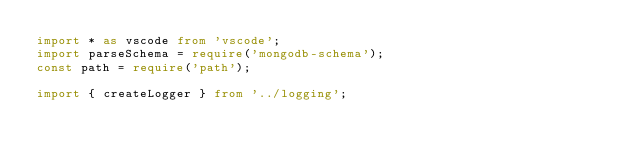<code> <loc_0><loc_0><loc_500><loc_500><_TypeScript_>import * as vscode from 'vscode';
import parseSchema = require('mongodb-schema');
const path = require('path');

import { createLogger } from '../logging';</code> 